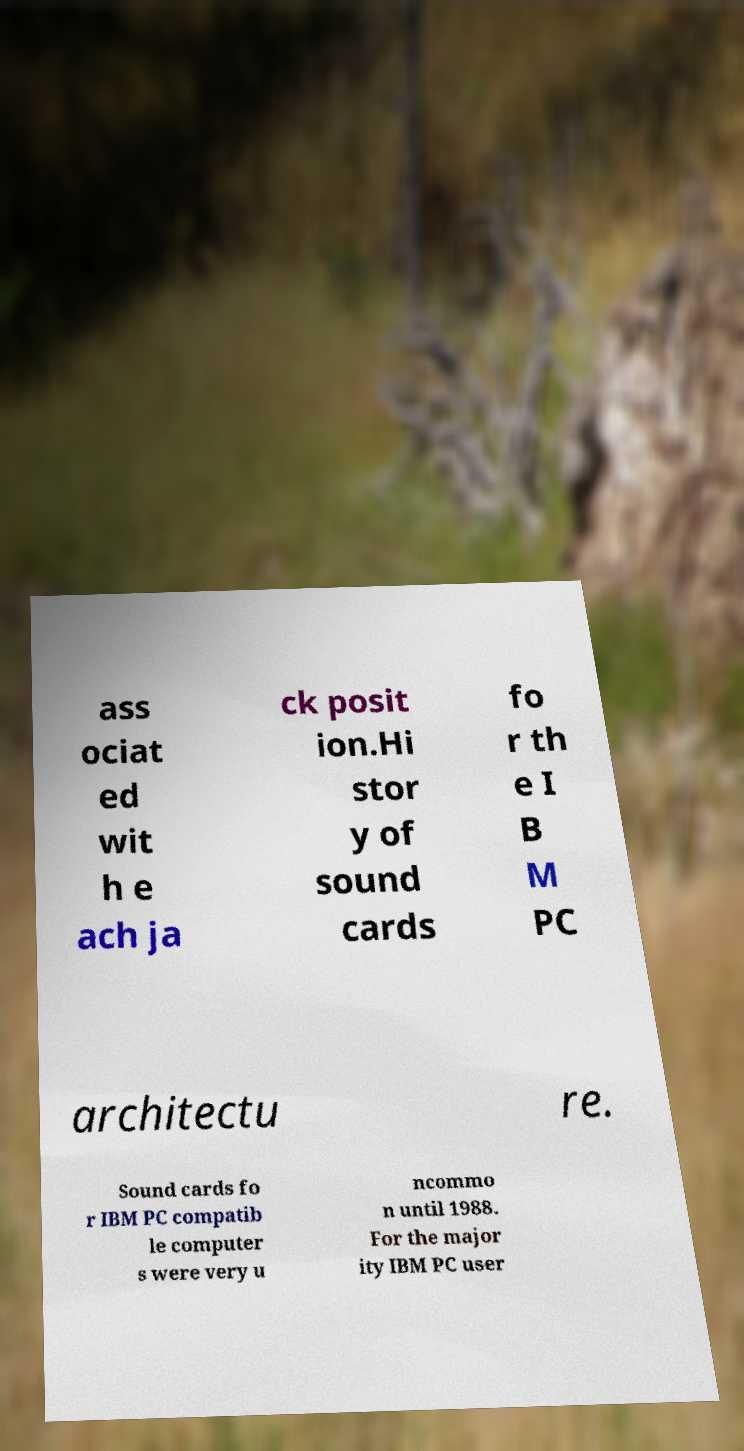What messages or text are displayed in this image? I need them in a readable, typed format. ass ociat ed wit h e ach ja ck posit ion.Hi stor y of sound cards fo r th e I B M PC architectu re. Sound cards fo r IBM PC compatib le computer s were very u ncommo n until 1988. For the major ity IBM PC user 